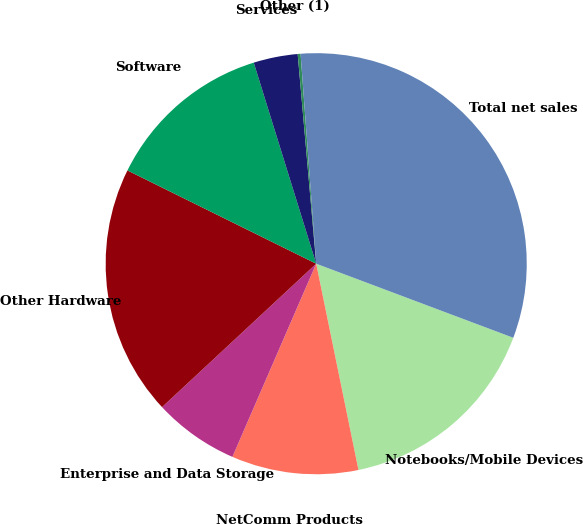Convert chart. <chart><loc_0><loc_0><loc_500><loc_500><pie_chart><fcel>Notebooks/Mobile Devices<fcel>NetComm Products<fcel>Enterprise and Data Storage<fcel>Other Hardware<fcel>Software<fcel>Services<fcel>Other (1)<fcel>Total net sales<nl><fcel>16.06%<fcel>9.73%<fcel>6.56%<fcel>19.23%<fcel>12.9%<fcel>3.39%<fcel>0.22%<fcel>31.9%<nl></chart> 